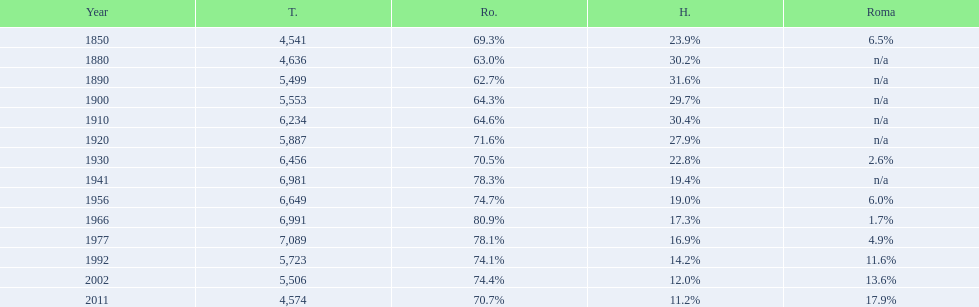In what year was the peak percentage of the romanian population recorded? 1966. 